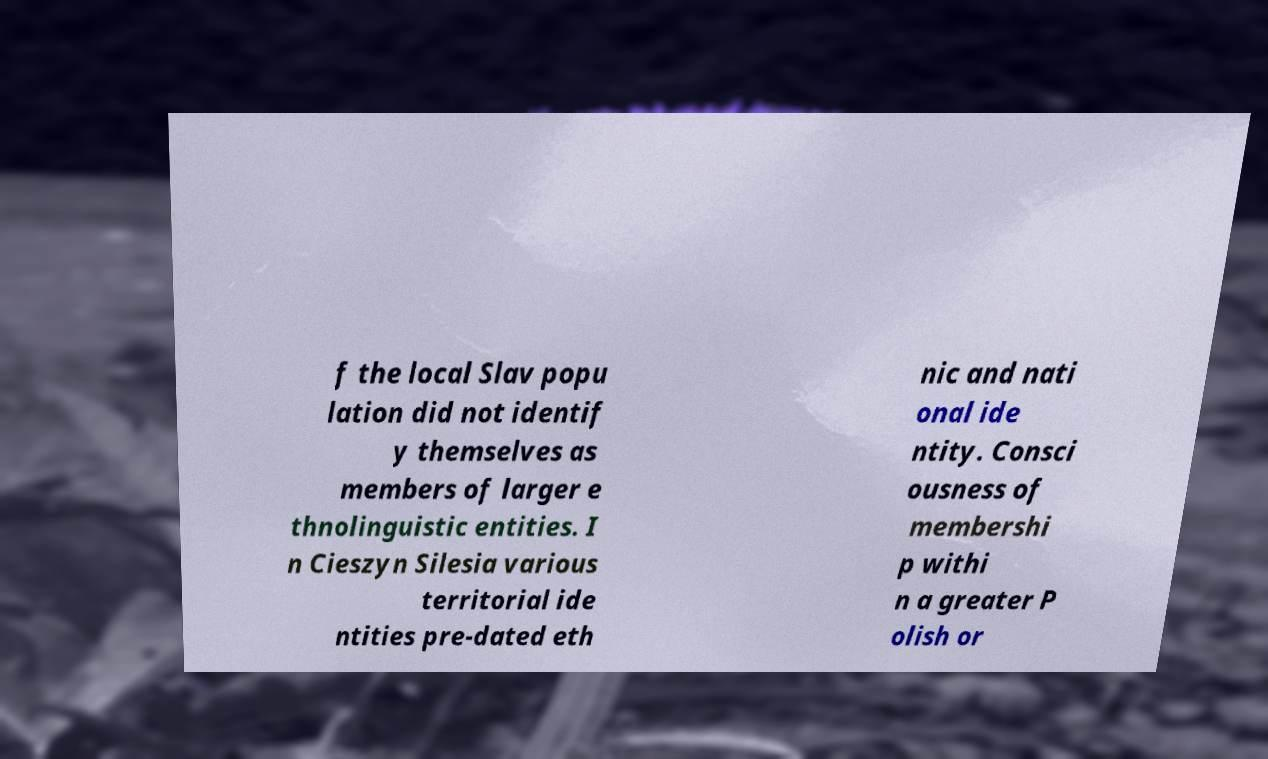I need the written content from this picture converted into text. Can you do that? f the local Slav popu lation did not identif y themselves as members of larger e thnolinguistic entities. I n Cieszyn Silesia various territorial ide ntities pre-dated eth nic and nati onal ide ntity. Consci ousness of membershi p withi n a greater P olish or 